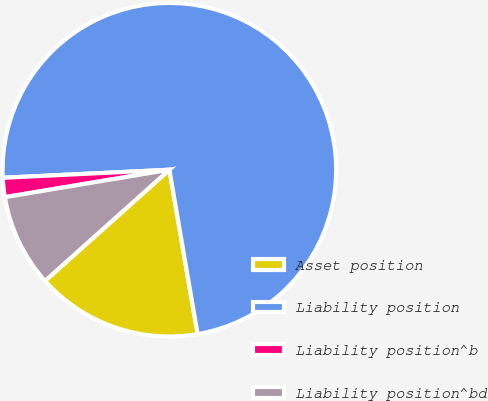Convert chart to OTSL. <chart><loc_0><loc_0><loc_500><loc_500><pie_chart><fcel>Asset position<fcel>Liability position<fcel>Liability position^b<fcel>Liability position^bd<nl><fcel>16.1%<fcel>73.06%<fcel>1.86%<fcel>8.98%<nl></chart> 